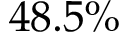<formula> <loc_0><loc_0><loc_500><loc_500>4 8 . 5 \%</formula> 